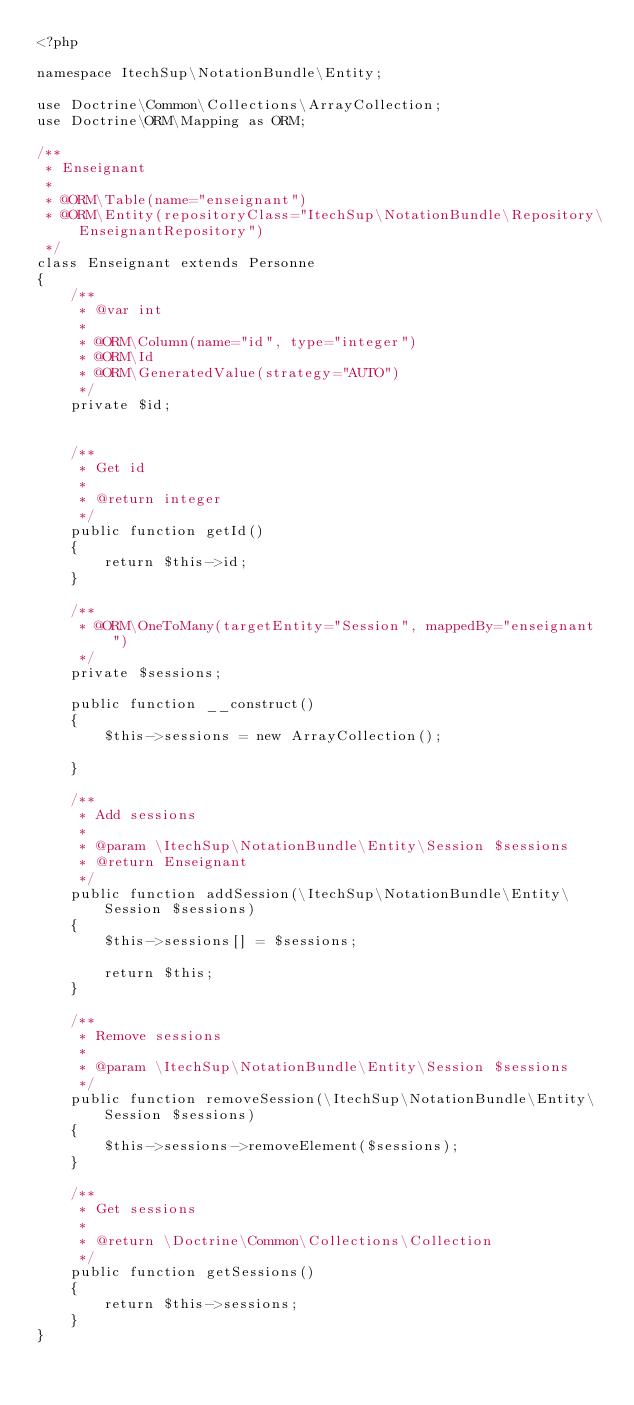<code> <loc_0><loc_0><loc_500><loc_500><_PHP_><?php

namespace ItechSup\NotationBundle\Entity;

use Doctrine\Common\Collections\ArrayCollection;
use Doctrine\ORM\Mapping as ORM;

/**
 * Enseignant
 *
 * @ORM\Table(name="enseignant")
 * @ORM\Entity(repositoryClass="ItechSup\NotationBundle\Repository\EnseignantRepository")
 */
class Enseignant extends Personne
{
    /**
     * @var int
     *
     * @ORM\Column(name="id", type="integer")
     * @ORM\Id
     * @ORM\GeneratedValue(strategy="AUTO")
     */
    private $id;


    /**
     * Get id
     *
     * @return integer
     */
    public function getId()
    {
        return $this->id;
    }

    /**
     * @ORM\OneToMany(targetEntity="Session", mappedBy="enseignant")
     */
    private $sessions;

    public function __construct()
    {
        $this->sessions = new ArrayCollection();

    }

    /**
     * Add sessions
     *
     * @param \ItechSup\NotationBundle\Entity\Session $sessions
     * @return Enseignant
     */
    public function addSession(\ItechSup\NotationBundle\Entity\Session $sessions)
    {
        $this->sessions[] = $sessions;

        return $this;
    }

    /**
     * Remove sessions
     *
     * @param \ItechSup\NotationBundle\Entity\Session $sessions
     */
    public function removeSession(\ItechSup\NotationBundle\Entity\Session $sessions)
    {
        $this->sessions->removeElement($sessions);
    }

    /**
     * Get sessions
     *
     * @return \Doctrine\Common\Collections\Collection 
     */
    public function getSessions()
    {
        return $this->sessions;
    }
}
</code> 